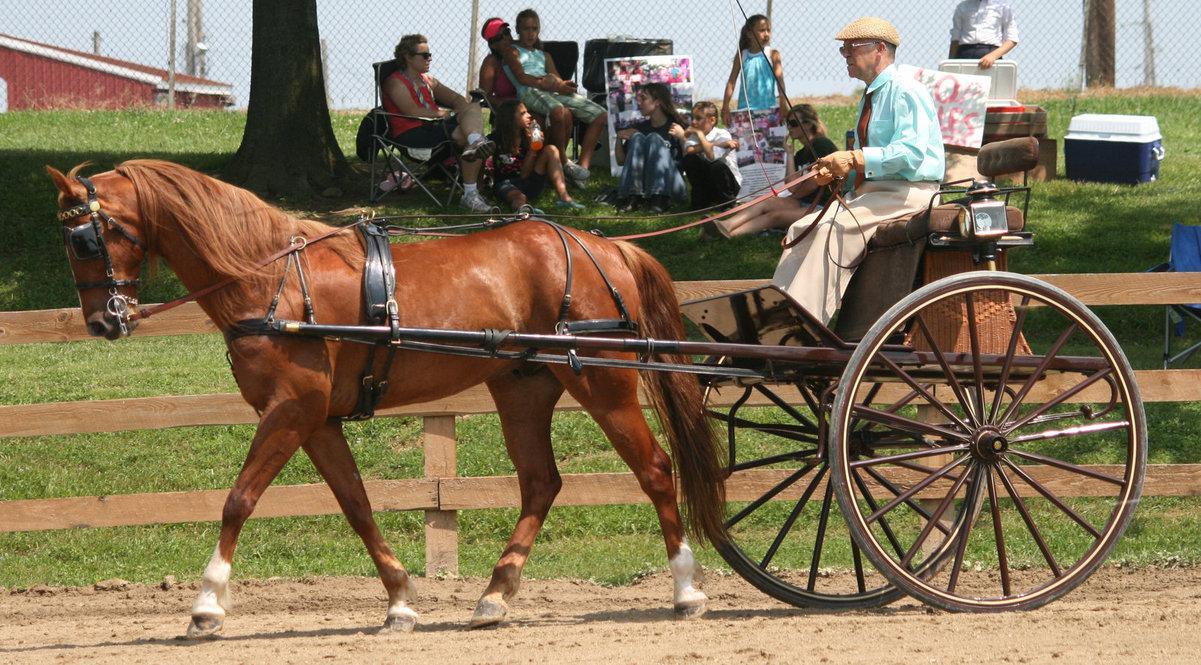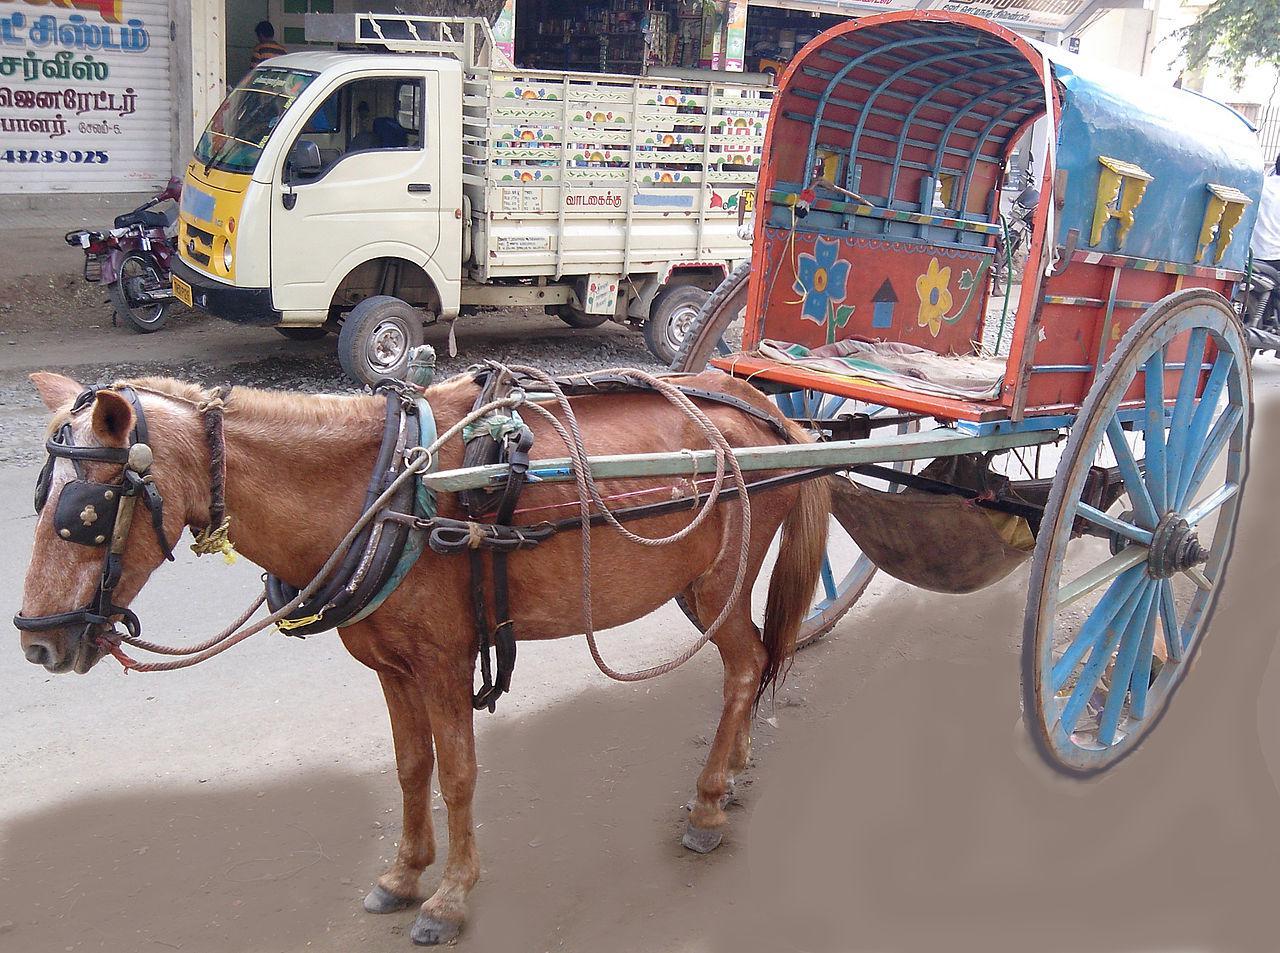The first image is the image on the left, the second image is the image on the right. For the images displayed, is the sentence "Both carts are pulled by brown horses." factually correct? Answer yes or no. Yes. 